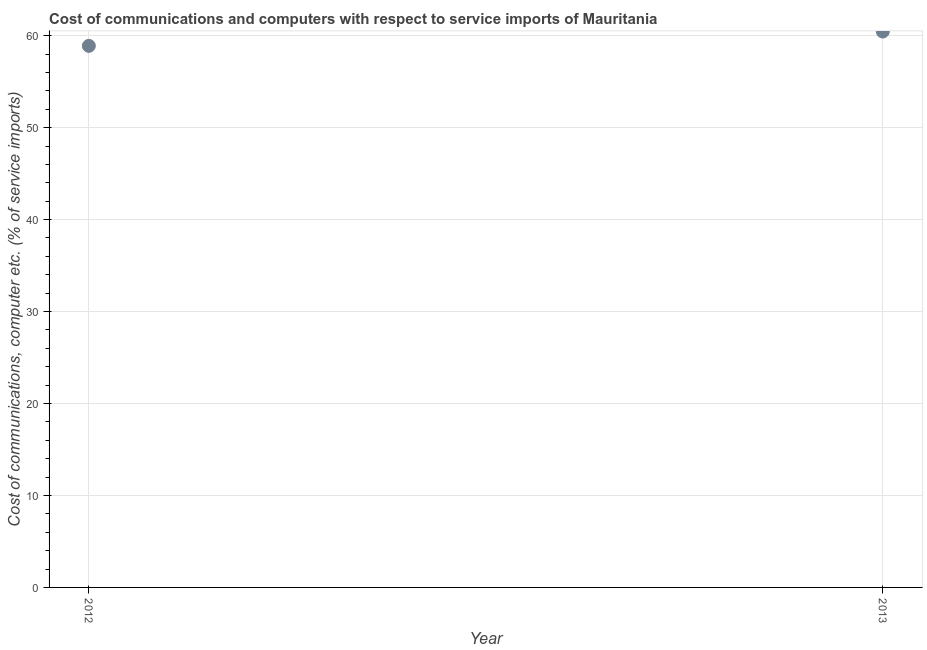What is the cost of communications and computer in 2013?
Your answer should be compact. 60.45. Across all years, what is the maximum cost of communications and computer?
Keep it short and to the point. 60.45. Across all years, what is the minimum cost of communications and computer?
Make the answer very short. 58.89. What is the sum of the cost of communications and computer?
Your answer should be very brief. 119.34. What is the difference between the cost of communications and computer in 2012 and 2013?
Give a very brief answer. -1.56. What is the average cost of communications and computer per year?
Your answer should be compact. 59.67. What is the median cost of communications and computer?
Your response must be concise. 59.67. Do a majority of the years between 2012 and 2013 (inclusive) have cost of communications and computer greater than 4 %?
Your answer should be very brief. Yes. What is the ratio of the cost of communications and computer in 2012 to that in 2013?
Give a very brief answer. 0.97. Is the cost of communications and computer in 2012 less than that in 2013?
Ensure brevity in your answer.  Yes. In how many years, is the cost of communications and computer greater than the average cost of communications and computer taken over all years?
Offer a terse response. 1. What is the difference between two consecutive major ticks on the Y-axis?
Make the answer very short. 10. Does the graph contain grids?
Make the answer very short. Yes. What is the title of the graph?
Give a very brief answer. Cost of communications and computers with respect to service imports of Mauritania. What is the label or title of the X-axis?
Provide a short and direct response. Year. What is the label or title of the Y-axis?
Your answer should be compact. Cost of communications, computer etc. (% of service imports). What is the Cost of communications, computer etc. (% of service imports) in 2012?
Your response must be concise. 58.89. What is the Cost of communications, computer etc. (% of service imports) in 2013?
Your answer should be very brief. 60.45. What is the difference between the Cost of communications, computer etc. (% of service imports) in 2012 and 2013?
Keep it short and to the point. -1.56. What is the ratio of the Cost of communications, computer etc. (% of service imports) in 2012 to that in 2013?
Ensure brevity in your answer.  0.97. 